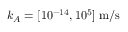<formula> <loc_0><loc_0><loc_500><loc_500>k _ { A } = [ 1 0 ^ { - 1 4 } , 1 0 ^ { 5 } ] \, m / s</formula> 